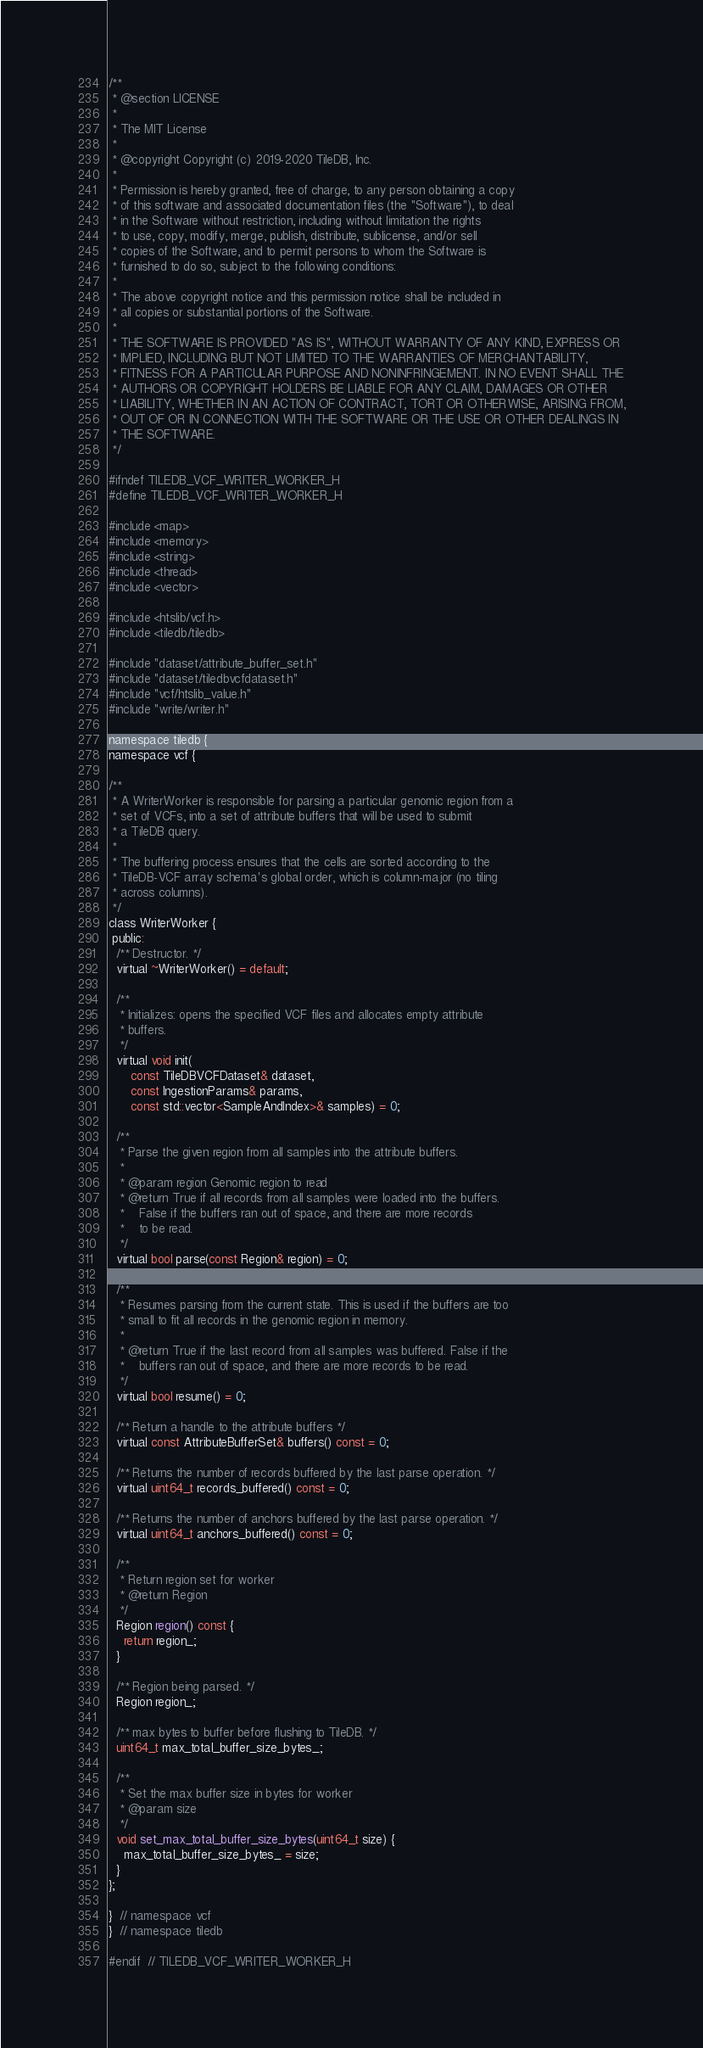Convert code to text. <code><loc_0><loc_0><loc_500><loc_500><_C_>/**
 * @section LICENSE
 *
 * The MIT License
 *
 * @copyright Copyright (c) 2019-2020 TileDB, Inc.
 *
 * Permission is hereby granted, free of charge, to any person obtaining a copy
 * of this software and associated documentation files (the "Software"), to deal
 * in the Software without restriction, including without limitation the rights
 * to use, copy, modify, merge, publish, distribute, sublicense, and/or sell
 * copies of the Software, and to permit persons to whom the Software is
 * furnished to do so, subject to the following conditions:
 *
 * The above copyright notice and this permission notice shall be included in
 * all copies or substantial portions of the Software.
 *
 * THE SOFTWARE IS PROVIDED "AS IS", WITHOUT WARRANTY OF ANY KIND, EXPRESS OR
 * IMPLIED, INCLUDING BUT NOT LIMITED TO THE WARRANTIES OF MERCHANTABILITY,
 * FITNESS FOR A PARTICULAR PURPOSE AND NONINFRINGEMENT. IN NO EVENT SHALL THE
 * AUTHORS OR COPYRIGHT HOLDERS BE LIABLE FOR ANY CLAIM, DAMAGES OR OTHER
 * LIABILITY, WHETHER IN AN ACTION OF CONTRACT, TORT OR OTHERWISE, ARISING FROM,
 * OUT OF OR IN CONNECTION WITH THE SOFTWARE OR THE USE OR OTHER DEALINGS IN
 * THE SOFTWARE.
 */

#ifndef TILEDB_VCF_WRITER_WORKER_H
#define TILEDB_VCF_WRITER_WORKER_H

#include <map>
#include <memory>
#include <string>
#include <thread>
#include <vector>

#include <htslib/vcf.h>
#include <tiledb/tiledb>

#include "dataset/attribute_buffer_set.h"
#include "dataset/tiledbvcfdataset.h"
#include "vcf/htslib_value.h"
#include "write/writer.h"

namespace tiledb {
namespace vcf {

/**
 * A WriterWorker is responsible for parsing a particular genomic region from a
 * set of VCFs, into a set of attribute buffers that will be used to submit
 * a TileDB query.
 *
 * The buffering process ensures that the cells are sorted according to the
 * TileDB-VCF array schema's global order, which is column-major (no tiling
 * across columns).
 */
class WriterWorker {
 public:
  /** Destructor. */
  virtual ~WriterWorker() = default;

  /**
   * Initializes: opens the specified VCF files and allocates empty attribute
   * buffers.
   */
  virtual void init(
      const TileDBVCFDataset& dataset,
      const IngestionParams& params,
      const std::vector<SampleAndIndex>& samples) = 0;

  /**
   * Parse the given region from all samples into the attribute buffers.
   *
   * @param region Genomic region to read
   * @return True if all records from all samples were loaded into the buffers.
   *    False if the buffers ran out of space, and there are more records
   *    to be read.
   */
  virtual bool parse(const Region& region) = 0;

  /**
   * Resumes parsing from the current state. This is used if the buffers are too
   * small to fit all records in the genomic region in memory.
   *
   * @return True if the last record from all samples was buffered. False if the
   *    buffers ran out of space, and there are more records to be read.
   */
  virtual bool resume() = 0;

  /** Return a handle to the attribute buffers */
  virtual const AttributeBufferSet& buffers() const = 0;

  /** Returns the number of records buffered by the last parse operation. */
  virtual uint64_t records_buffered() const = 0;

  /** Returns the number of anchors buffered by the last parse operation. */
  virtual uint64_t anchors_buffered() const = 0;

  /**
   * Return region set for worker
   * @return Region
   */
  Region region() const {
    return region_;
  }

  /** Region being parsed. */
  Region region_;

  /** max bytes to buffer before flushing to TileDB. */
  uint64_t max_total_buffer_size_bytes_;

  /**
   * Set the max buffer size in bytes for worker
   * @param size
   */
  void set_max_total_buffer_size_bytes(uint64_t size) {
    max_total_buffer_size_bytes_ = size;
  }
};

}  // namespace vcf
}  // namespace tiledb

#endif  // TILEDB_VCF_WRITER_WORKER_H
</code> 